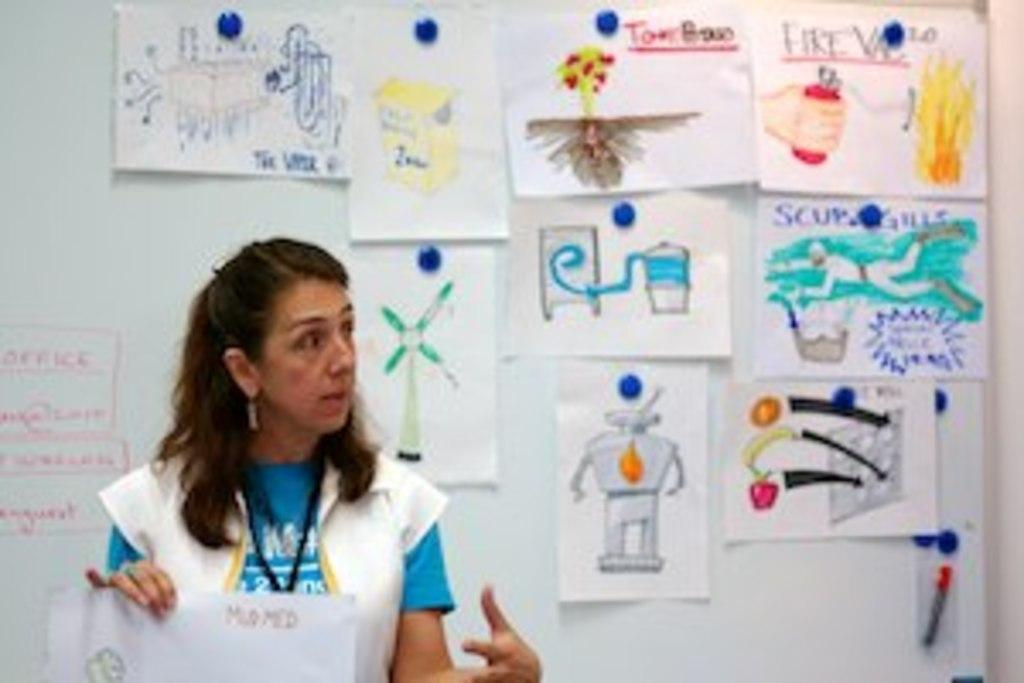What is the woman in the image doing with her hand? The woman is holding a paper in her hand. What can be seen in the background of the image? There is a wall in the background of the image. What is on the wall in the image? There are papers on the wall, and they have pictures on them. What type of honey is dripping from the pipe in the image? There is no honey or pipe present in the image. How many rings can be seen on the woman's finger in the image? There is no ring visible on the woman's finger in the image. 